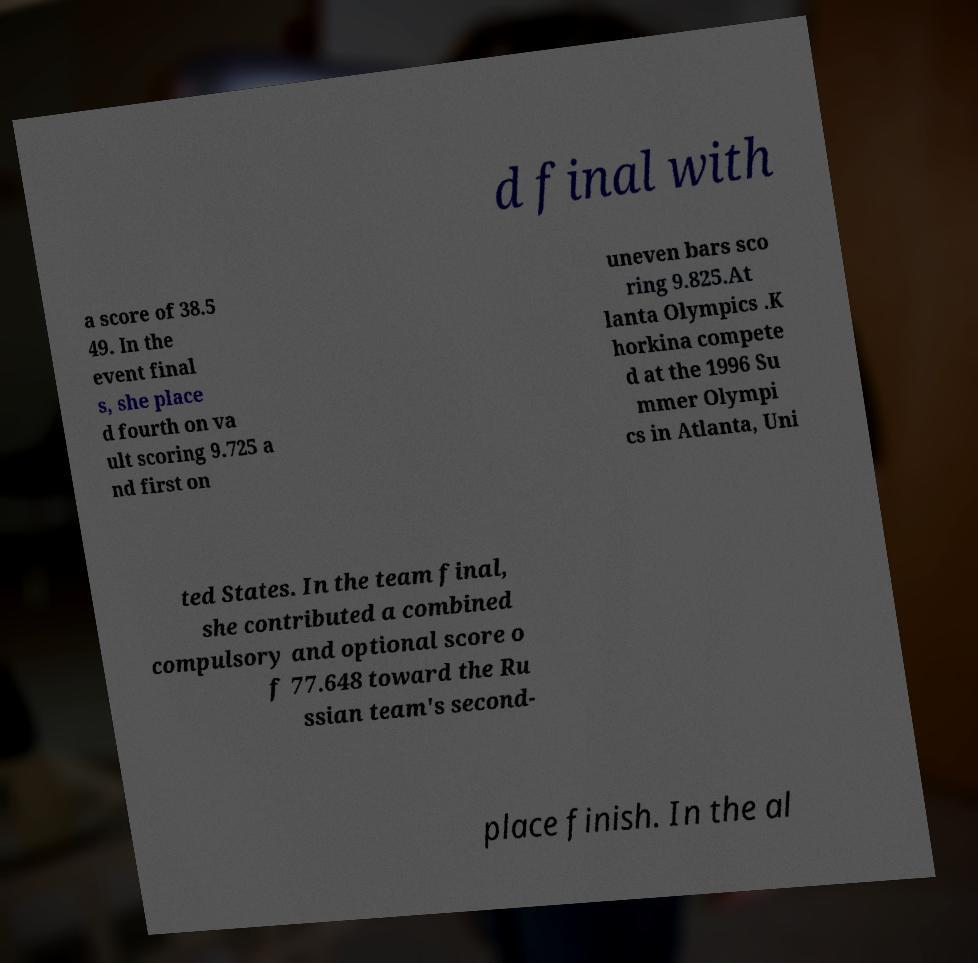There's text embedded in this image that I need extracted. Can you transcribe it verbatim? d final with a score of 38.5 49. In the event final s, she place d fourth on va ult scoring 9.725 a nd first on uneven bars sco ring 9.825.At lanta Olympics .K horkina compete d at the 1996 Su mmer Olympi cs in Atlanta, Uni ted States. In the team final, she contributed a combined compulsory and optional score o f 77.648 toward the Ru ssian team's second- place finish. In the al 